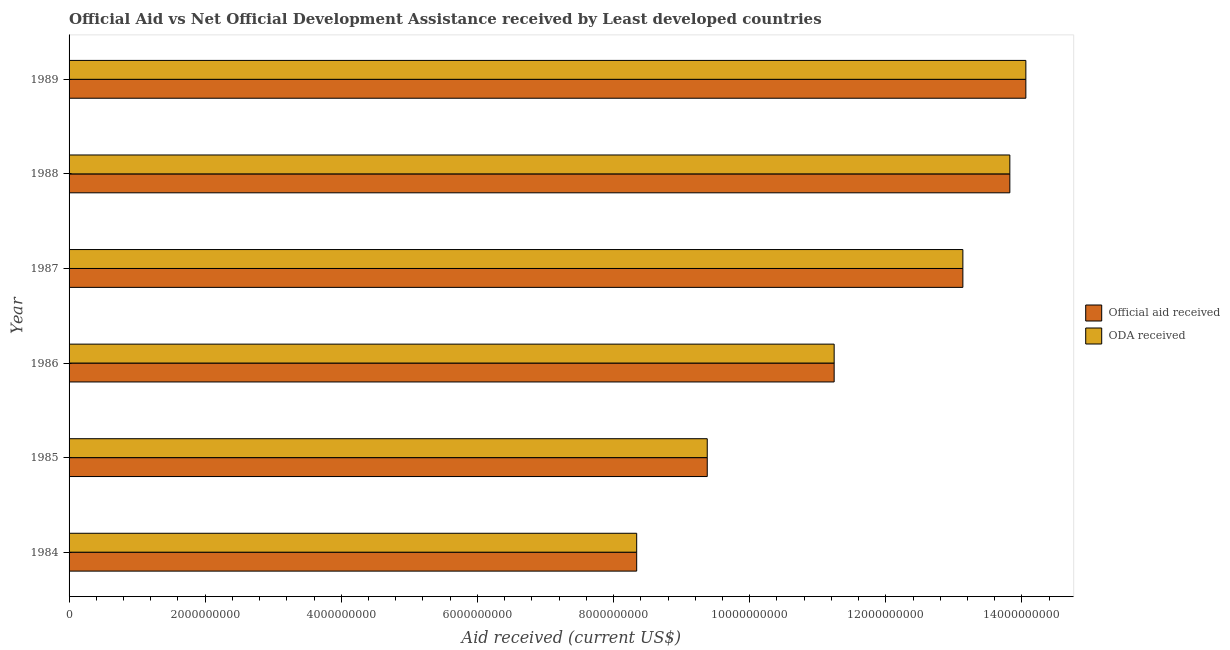How many different coloured bars are there?
Provide a succinct answer. 2. Are the number of bars per tick equal to the number of legend labels?
Your response must be concise. Yes. What is the oda received in 1984?
Your answer should be very brief. 8.34e+09. Across all years, what is the maximum official aid received?
Provide a succinct answer. 1.41e+1. Across all years, what is the minimum official aid received?
Offer a very short reply. 8.34e+09. In which year was the official aid received maximum?
Make the answer very short. 1989. In which year was the oda received minimum?
Offer a very short reply. 1984. What is the total official aid received in the graph?
Provide a succinct answer. 7.00e+1. What is the difference between the oda received in 1985 and that in 1988?
Keep it short and to the point. -4.45e+09. What is the difference between the oda received in 1984 and the official aid received in 1987?
Provide a short and direct response. -4.79e+09. What is the average oda received per year?
Provide a short and direct response. 1.17e+1. In how many years, is the oda received greater than 10000000000 US$?
Give a very brief answer. 4. What is the ratio of the oda received in 1984 to that in 1987?
Provide a short and direct response. 0.64. Is the difference between the oda received in 1984 and 1986 greater than the difference between the official aid received in 1984 and 1986?
Your answer should be very brief. No. What is the difference between the highest and the second highest oda received?
Keep it short and to the point. 2.35e+08. What is the difference between the highest and the lowest oda received?
Offer a very short reply. 5.72e+09. What does the 1st bar from the top in 1986 represents?
Provide a short and direct response. ODA received. What does the 2nd bar from the bottom in 1985 represents?
Offer a terse response. ODA received. How many bars are there?
Your response must be concise. 12. How many years are there in the graph?
Ensure brevity in your answer.  6. Are the values on the major ticks of X-axis written in scientific E-notation?
Your answer should be very brief. No. Does the graph contain grids?
Ensure brevity in your answer.  No. What is the title of the graph?
Keep it short and to the point. Official Aid vs Net Official Development Assistance received by Least developed countries . What is the label or title of the X-axis?
Offer a very short reply. Aid received (current US$). What is the Aid received (current US$) of Official aid received in 1984?
Your answer should be very brief. 8.34e+09. What is the Aid received (current US$) of ODA received in 1984?
Give a very brief answer. 8.34e+09. What is the Aid received (current US$) in Official aid received in 1985?
Offer a terse response. 9.38e+09. What is the Aid received (current US$) in ODA received in 1985?
Ensure brevity in your answer.  9.38e+09. What is the Aid received (current US$) of Official aid received in 1986?
Offer a terse response. 1.12e+1. What is the Aid received (current US$) of ODA received in 1986?
Make the answer very short. 1.12e+1. What is the Aid received (current US$) in Official aid received in 1987?
Your answer should be compact. 1.31e+1. What is the Aid received (current US$) of ODA received in 1987?
Ensure brevity in your answer.  1.31e+1. What is the Aid received (current US$) of Official aid received in 1988?
Offer a very short reply. 1.38e+1. What is the Aid received (current US$) in ODA received in 1988?
Provide a succinct answer. 1.38e+1. What is the Aid received (current US$) in Official aid received in 1989?
Your answer should be compact. 1.41e+1. What is the Aid received (current US$) in ODA received in 1989?
Your answer should be very brief. 1.41e+1. Across all years, what is the maximum Aid received (current US$) of Official aid received?
Your answer should be very brief. 1.41e+1. Across all years, what is the maximum Aid received (current US$) of ODA received?
Make the answer very short. 1.41e+1. Across all years, what is the minimum Aid received (current US$) of Official aid received?
Your response must be concise. 8.34e+09. Across all years, what is the minimum Aid received (current US$) of ODA received?
Your answer should be compact. 8.34e+09. What is the total Aid received (current US$) in Official aid received in the graph?
Your response must be concise. 7.00e+1. What is the total Aid received (current US$) of ODA received in the graph?
Ensure brevity in your answer.  7.00e+1. What is the difference between the Aid received (current US$) in Official aid received in 1984 and that in 1985?
Provide a short and direct response. -1.04e+09. What is the difference between the Aid received (current US$) in ODA received in 1984 and that in 1985?
Keep it short and to the point. -1.04e+09. What is the difference between the Aid received (current US$) of Official aid received in 1984 and that in 1986?
Make the answer very short. -2.90e+09. What is the difference between the Aid received (current US$) in ODA received in 1984 and that in 1986?
Offer a very short reply. -2.90e+09. What is the difference between the Aid received (current US$) of Official aid received in 1984 and that in 1987?
Give a very brief answer. -4.79e+09. What is the difference between the Aid received (current US$) of ODA received in 1984 and that in 1987?
Offer a terse response. -4.79e+09. What is the difference between the Aid received (current US$) of Official aid received in 1984 and that in 1988?
Your answer should be very brief. -5.48e+09. What is the difference between the Aid received (current US$) of ODA received in 1984 and that in 1988?
Your answer should be compact. -5.48e+09. What is the difference between the Aid received (current US$) of Official aid received in 1984 and that in 1989?
Give a very brief answer. -5.72e+09. What is the difference between the Aid received (current US$) of ODA received in 1984 and that in 1989?
Give a very brief answer. -5.72e+09. What is the difference between the Aid received (current US$) in Official aid received in 1985 and that in 1986?
Your answer should be compact. -1.86e+09. What is the difference between the Aid received (current US$) of ODA received in 1985 and that in 1986?
Provide a succinct answer. -1.86e+09. What is the difference between the Aid received (current US$) in Official aid received in 1985 and that in 1987?
Provide a succinct answer. -3.76e+09. What is the difference between the Aid received (current US$) of ODA received in 1985 and that in 1987?
Keep it short and to the point. -3.76e+09. What is the difference between the Aid received (current US$) of Official aid received in 1985 and that in 1988?
Make the answer very short. -4.45e+09. What is the difference between the Aid received (current US$) of ODA received in 1985 and that in 1988?
Keep it short and to the point. -4.45e+09. What is the difference between the Aid received (current US$) in Official aid received in 1985 and that in 1989?
Provide a succinct answer. -4.68e+09. What is the difference between the Aid received (current US$) of ODA received in 1985 and that in 1989?
Your answer should be very brief. -4.68e+09. What is the difference between the Aid received (current US$) in Official aid received in 1986 and that in 1987?
Offer a very short reply. -1.89e+09. What is the difference between the Aid received (current US$) in ODA received in 1986 and that in 1987?
Offer a terse response. -1.89e+09. What is the difference between the Aid received (current US$) in Official aid received in 1986 and that in 1988?
Provide a succinct answer. -2.58e+09. What is the difference between the Aid received (current US$) in ODA received in 1986 and that in 1988?
Offer a terse response. -2.58e+09. What is the difference between the Aid received (current US$) of Official aid received in 1986 and that in 1989?
Ensure brevity in your answer.  -2.82e+09. What is the difference between the Aid received (current US$) in ODA received in 1986 and that in 1989?
Keep it short and to the point. -2.82e+09. What is the difference between the Aid received (current US$) of Official aid received in 1987 and that in 1988?
Make the answer very short. -6.90e+08. What is the difference between the Aid received (current US$) of ODA received in 1987 and that in 1988?
Ensure brevity in your answer.  -6.90e+08. What is the difference between the Aid received (current US$) in Official aid received in 1987 and that in 1989?
Your answer should be compact. -9.25e+08. What is the difference between the Aid received (current US$) in ODA received in 1987 and that in 1989?
Keep it short and to the point. -9.25e+08. What is the difference between the Aid received (current US$) of Official aid received in 1988 and that in 1989?
Make the answer very short. -2.35e+08. What is the difference between the Aid received (current US$) of ODA received in 1988 and that in 1989?
Offer a very short reply. -2.35e+08. What is the difference between the Aid received (current US$) of Official aid received in 1984 and the Aid received (current US$) of ODA received in 1985?
Give a very brief answer. -1.04e+09. What is the difference between the Aid received (current US$) of Official aid received in 1984 and the Aid received (current US$) of ODA received in 1986?
Offer a very short reply. -2.90e+09. What is the difference between the Aid received (current US$) of Official aid received in 1984 and the Aid received (current US$) of ODA received in 1987?
Offer a very short reply. -4.79e+09. What is the difference between the Aid received (current US$) of Official aid received in 1984 and the Aid received (current US$) of ODA received in 1988?
Provide a succinct answer. -5.48e+09. What is the difference between the Aid received (current US$) in Official aid received in 1984 and the Aid received (current US$) in ODA received in 1989?
Offer a very short reply. -5.72e+09. What is the difference between the Aid received (current US$) of Official aid received in 1985 and the Aid received (current US$) of ODA received in 1986?
Provide a short and direct response. -1.86e+09. What is the difference between the Aid received (current US$) in Official aid received in 1985 and the Aid received (current US$) in ODA received in 1987?
Provide a short and direct response. -3.76e+09. What is the difference between the Aid received (current US$) of Official aid received in 1985 and the Aid received (current US$) of ODA received in 1988?
Provide a succinct answer. -4.45e+09. What is the difference between the Aid received (current US$) in Official aid received in 1985 and the Aid received (current US$) in ODA received in 1989?
Provide a succinct answer. -4.68e+09. What is the difference between the Aid received (current US$) of Official aid received in 1986 and the Aid received (current US$) of ODA received in 1987?
Keep it short and to the point. -1.89e+09. What is the difference between the Aid received (current US$) in Official aid received in 1986 and the Aid received (current US$) in ODA received in 1988?
Provide a short and direct response. -2.58e+09. What is the difference between the Aid received (current US$) of Official aid received in 1986 and the Aid received (current US$) of ODA received in 1989?
Offer a very short reply. -2.82e+09. What is the difference between the Aid received (current US$) in Official aid received in 1987 and the Aid received (current US$) in ODA received in 1988?
Provide a succinct answer. -6.90e+08. What is the difference between the Aid received (current US$) in Official aid received in 1987 and the Aid received (current US$) in ODA received in 1989?
Provide a succinct answer. -9.25e+08. What is the difference between the Aid received (current US$) in Official aid received in 1988 and the Aid received (current US$) in ODA received in 1989?
Keep it short and to the point. -2.35e+08. What is the average Aid received (current US$) in Official aid received per year?
Ensure brevity in your answer.  1.17e+1. What is the average Aid received (current US$) in ODA received per year?
Offer a terse response. 1.17e+1. In the year 1986, what is the difference between the Aid received (current US$) in Official aid received and Aid received (current US$) in ODA received?
Your answer should be very brief. 0. In the year 1988, what is the difference between the Aid received (current US$) of Official aid received and Aid received (current US$) of ODA received?
Keep it short and to the point. 0. In the year 1989, what is the difference between the Aid received (current US$) in Official aid received and Aid received (current US$) in ODA received?
Your response must be concise. 0. What is the ratio of the Aid received (current US$) of Official aid received in 1984 to that in 1985?
Your answer should be very brief. 0.89. What is the ratio of the Aid received (current US$) in ODA received in 1984 to that in 1985?
Give a very brief answer. 0.89. What is the ratio of the Aid received (current US$) in Official aid received in 1984 to that in 1986?
Keep it short and to the point. 0.74. What is the ratio of the Aid received (current US$) of ODA received in 1984 to that in 1986?
Offer a very short reply. 0.74. What is the ratio of the Aid received (current US$) in Official aid received in 1984 to that in 1987?
Give a very brief answer. 0.64. What is the ratio of the Aid received (current US$) in ODA received in 1984 to that in 1987?
Your answer should be very brief. 0.64. What is the ratio of the Aid received (current US$) in Official aid received in 1984 to that in 1988?
Ensure brevity in your answer.  0.6. What is the ratio of the Aid received (current US$) in ODA received in 1984 to that in 1988?
Your answer should be compact. 0.6. What is the ratio of the Aid received (current US$) in Official aid received in 1984 to that in 1989?
Keep it short and to the point. 0.59. What is the ratio of the Aid received (current US$) of ODA received in 1984 to that in 1989?
Offer a terse response. 0.59. What is the ratio of the Aid received (current US$) of Official aid received in 1985 to that in 1986?
Keep it short and to the point. 0.83. What is the ratio of the Aid received (current US$) in ODA received in 1985 to that in 1986?
Your answer should be compact. 0.83. What is the ratio of the Aid received (current US$) of Official aid received in 1985 to that in 1987?
Provide a short and direct response. 0.71. What is the ratio of the Aid received (current US$) of ODA received in 1985 to that in 1987?
Provide a succinct answer. 0.71. What is the ratio of the Aid received (current US$) of Official aid received in 1985 to that in 1988?
Your response must be concise. 0.68. What is the ratio of the Aid received (current US$) in ODA received in 1985 to that in 1988?
Ensure brevity in your answer.  0.68. What is the ratio of the Aid received (current US$) in Official aid received in 1985 to that in 1989?
Ensure brevity in your answer.  0.67. What is the ratio of the Aid received (current US$) of ODA received in 1985 to that in 1989?
Your response must be concise. 0.67. What is the ratio of the Aid received (current US$) of Official aid received in 1986 to that in 1987?
Offer a terse response. 0.86. What is the ratio of the Aid received (current US$) of ODA received in 1986 to that in 1987?
Provide a short and direct response. 0.86. What is the ratio of the Aid received (current US$) in Official aid received in 1986 to that in 1988?
Offer a terse response. 0.81. What is the ratio of the Aid received (current US$) of ODA received in 1986 to that in 1988?
Provide a succinct answer. 0.81. What is the ratio of the Aid received (current US$) of Official aid received in 1986 to that in 1989?
Your answer should be compact. 0.8. What is the ratio of the Aid received (current US$) of ODA received in 1986 to that in 1989?
Your response must be concise. 0.8. What is the ratio of the Aid received (current US$) in Official aid received in 1987 to that in 1988?
Your answer should be very brief. 0.95. What is the ratio of the Aid received (current US$) of ODA received in 1987 to that in 1988?
Provide a succinct answer. 0.95. What is the ratio of the Aid received (current US$) of Official aid received in 1987 to that in 1989?
Give a very brief answer. 0.93. What is the ratio of the Aid received (current US$) of ODA received in 1987 to that in 1989?
Your response must be concise. 0.93. What is the ratio of the Aid received (current US$) in Official aid received in 1988 to that in 1989?
Provide a short and direct response. 0.98. What is the ratio of the Aid received (current US$) of ODA received in 1988 to that in 1989?
Make the answer very short. 0.98. What is the difference between the highest and the second highest Aid received (current US$) in Official aid received?
Make the answer very short. 2.35e+08. What is the difference between the highest and the second highest Aid received (current US$) in ODA received?
Offer a very short reply. 2.35e+08. What is the difference between the highest and the lowest Aid received (current US$) in Official aid received?
Your answer should be very brief. 5.72e+09. What is the difference between the highest and the lowest Aid received (current US$) of ODA received?
Keep it short and to the point. 5.72e+09. 